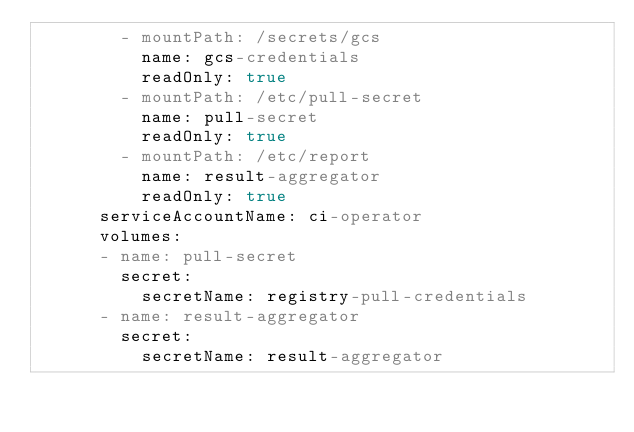<code> <loc_0><loc_0><loc_500><loc_500><_YAML_>        - mountPath: /secrets/gcs
          name: gcs-credentials
          readOnly: true
        - mountPath: /etc/pull-secret
          name: pull-secret
          readOnly: true
        - mountPath: /etc/report
          name: result-aggregator
          readOnly: true
      serviceAccountName: ci-operator
      volumes:
      - name: pull-secret
        secret:
          secretName: registry-pull-credentials
      - name: result-aggregator
        secret:
          secretName: result-aggregator</code> 